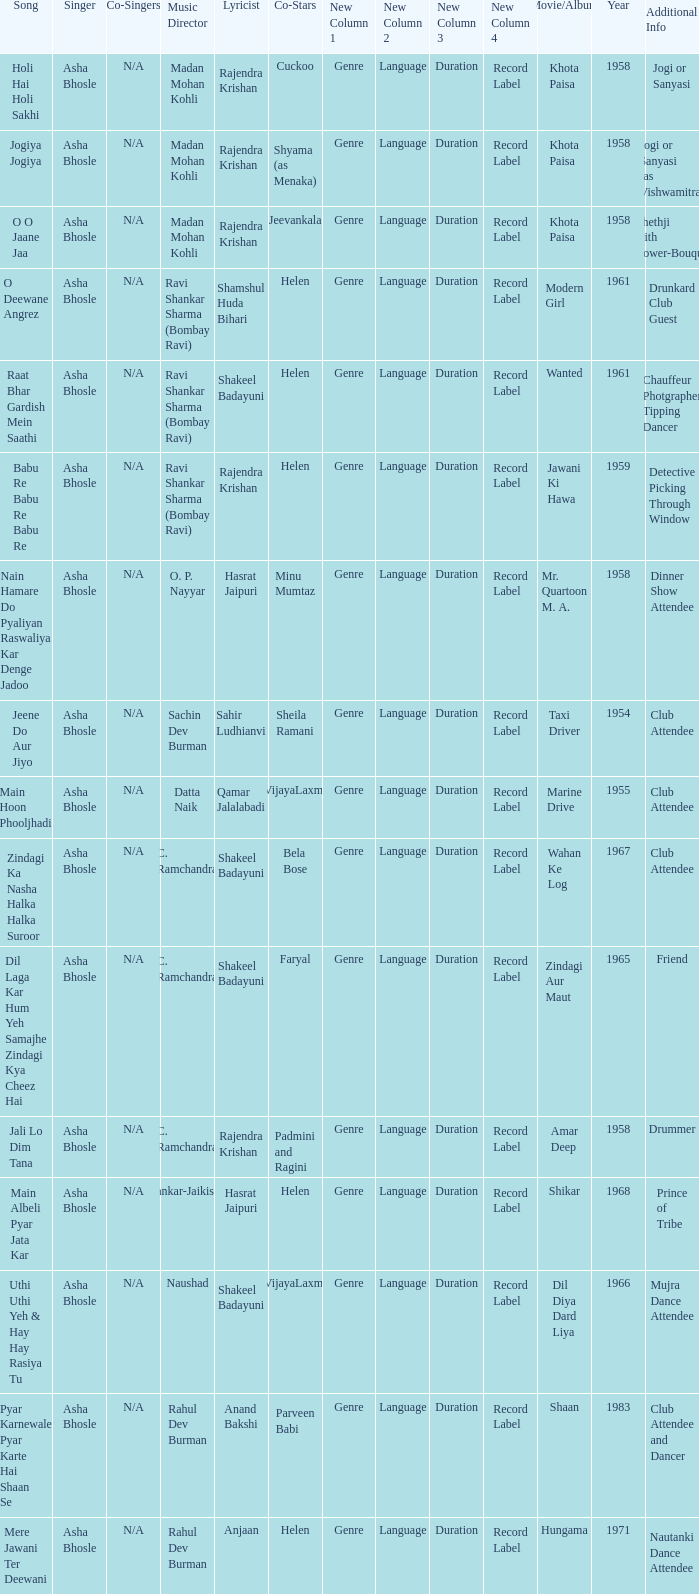How many co-singers were there when Parveen Babi co-starred? 1.0. 